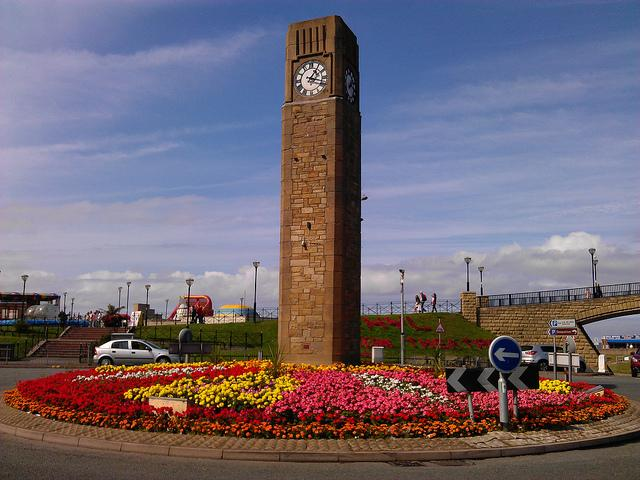What is the traffic pattern? roundabout 